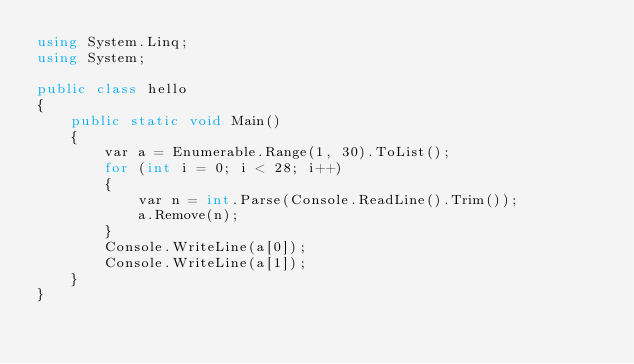<code> <loc_0><loc_0><loc_500><loc_500><_C#_>using System.Linq;
using System;

public class hello
{
    public static void Main()
    {
        var a = Enumerable.Range(1, 30).ToList();
        for (int i = 0; i < 28; i++)
        {
            var n = int.Parse(Console.ReadLine().Trim());
            a.Remove(n);
        }
        Console.WriteLine(a[0]);
        Console.WriteLine(a[1]);
    }
}</code> 